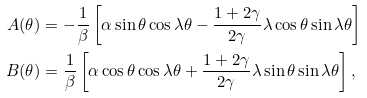Convert formula to latex. <formula><loc_0><loc_0><loc_500><loc_500>A ( \theta ) & = - \frac { 1 } { \beta } \left [ \alpha \sin \theta \cos \lambda \theta - \frac { 1 + 2 \gamma } { 2 \gamma } \lambda \cos \theta \sin \lambda \theta \right ] \\ B ( \theta ) & = \frac { 1 } { \beta } \left [ \alpha \cos \theta \cos \lambda \theta + \frac { 1 + 2 \gamma } { 2 \gamma } \lambda \sin \theta \sin \lambda \theta \right ] ,</formula> 